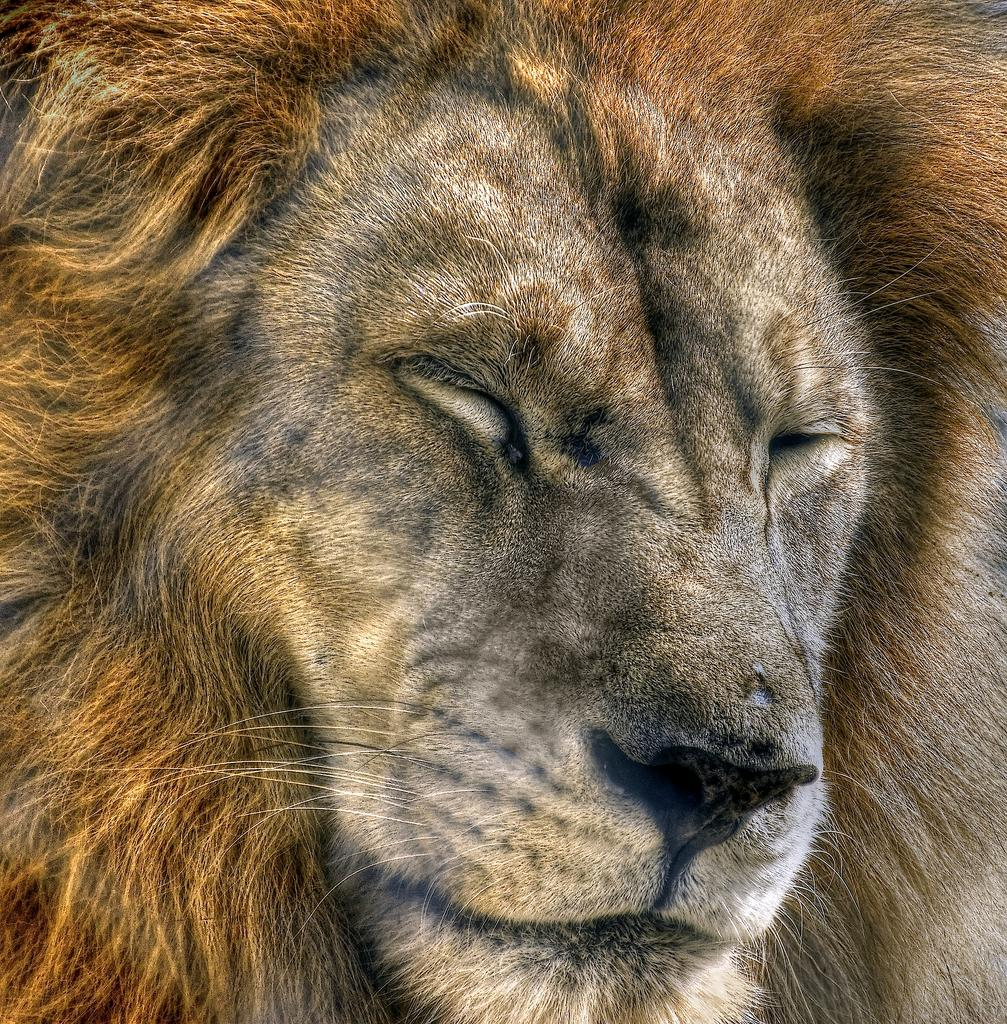What is the main subject of the image? The main subject of the image is the face of a lion. What type of flesh can be seen in the image? There is no flesh visible in the image, as it features the face of a lion. 